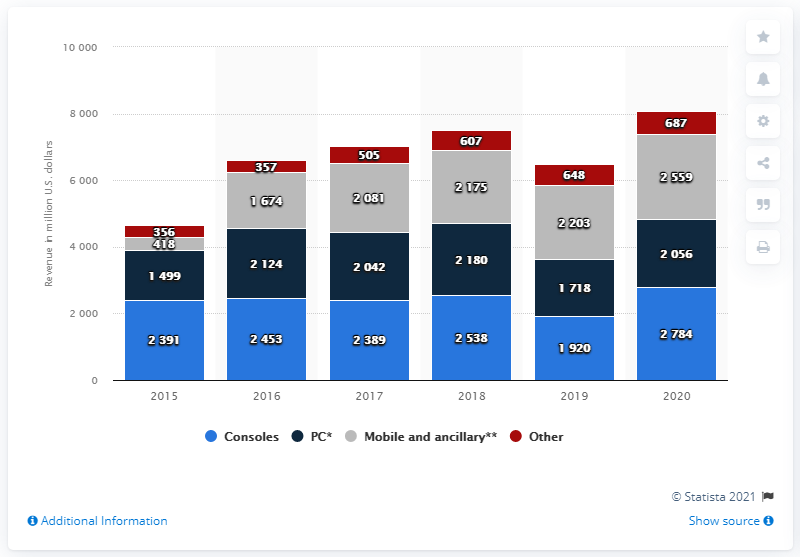Draw attention to some important aspects in this diagram. Activision Blizzard's console segment generated approximately $27.84 billion in annual revenues in 2020. The net revenue of consoles in 2020 was 2784. The average revenue of PCs from 2016 to 2017 was approximately 2083. 